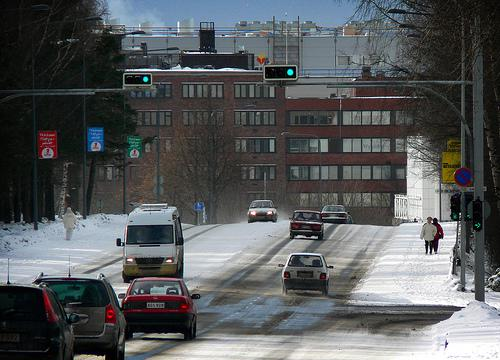Question: where is snow?
Choices:
A. On the ground.
B. On the roof.
C. In the tree.
D. Above the garage.
Answer with the letter. Answer: A Question: what is lit green?
Choices:
A. Candle.
B. Wall.
C. Basket.
D. Traffic lights.
Answer with the letter. Answer: D Question: when was the picture taken?
Choices:
A. Night.
B. Sunset.
C. New Year's Day.
D. Daytime.
Answer with the letter. Answer: D Question: where are windows?
Choices:
A. On buildings.
B. In cars.
C. In cottages.
D. In huts.
Answer with the letter. Answer: A Question: what is brown?
Choices:
A. A hat.
B. A box.
C. A building.
D. A car.
Answer with the letter. Answer: C Question: what is blue?
Choices:
A. Sky.
B. Kite.
C. Ground.
D. Plane.
Answer with the letter. Answer: A 